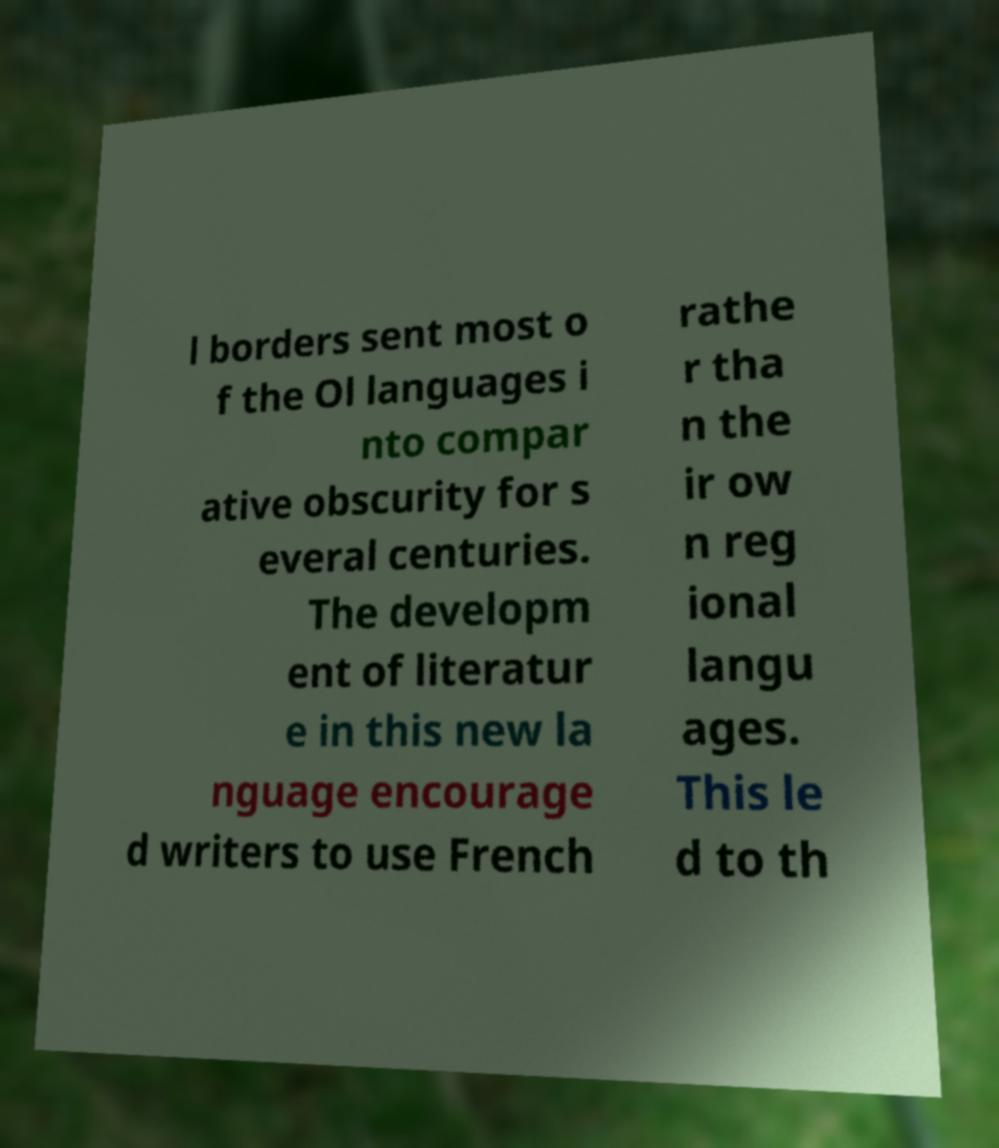Can you accurately transcribe the text from the provided image for me? l borders sent most o f the Ol languages i nto compar ative obscurity for s everal centuries. The developm ent of literatur e in this new la nguage encourage d writers to use French rathe r tha n the ir ow n reg ional langu ages. This le d to th 